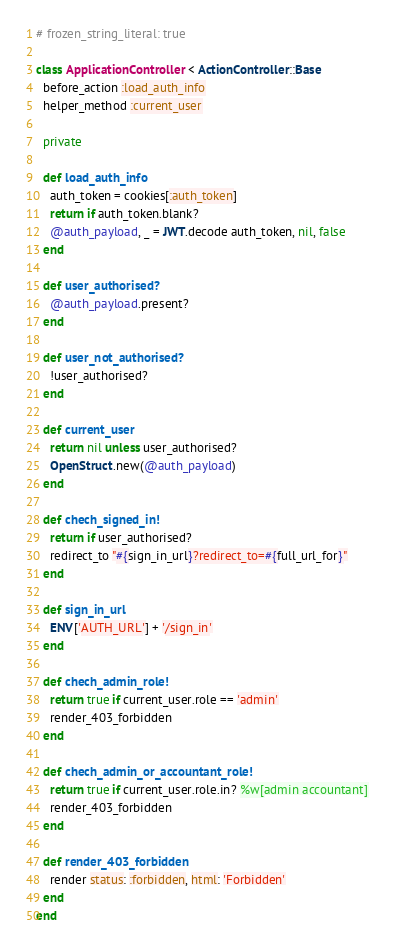Convert code to text. <code><loc_0><loc_0><loc_500><loc_500><_Ruby_># frozen_string_literal: true

class ApplicationController < ActionController::Base
  before_action :load_auth_info
  helper_method :current_user

  private

  def load_auth_info
    auth_token = cookies[:auth_token]
    return if auth_token.blank?
    @auth_payload, _ = JWT.decode auth_token, nil, false
  end

  def user_authorised?
    @auth_payload.present?
  end

  def user_not_authorised?
    !user_authorised?
  end

  def current_user
    return nil unless user_authorised?
    OpenStruct.new(@auth_payload)
  end

  def chech_signed_in!
    return if user_authorised?
    redirect_to "#{sign_in_url}?redirect_to=#{full_url_for}"
  end

  def sign_in_url
    ENV['AUTH_URL'] + '/sign_in'
  end

  def chech_admin_role!
    return true if current_user.role == 'admin'
    render_403_forbidden
  end

  def chech_admin_or_accountant_role!
    return true if current_user.role.in? %w[admin accountant]
    render_403_forbidden
  end

  def render_403_forbidden
    render status: :forbidden, html: 'Forbidden'
  end
end
</code> 